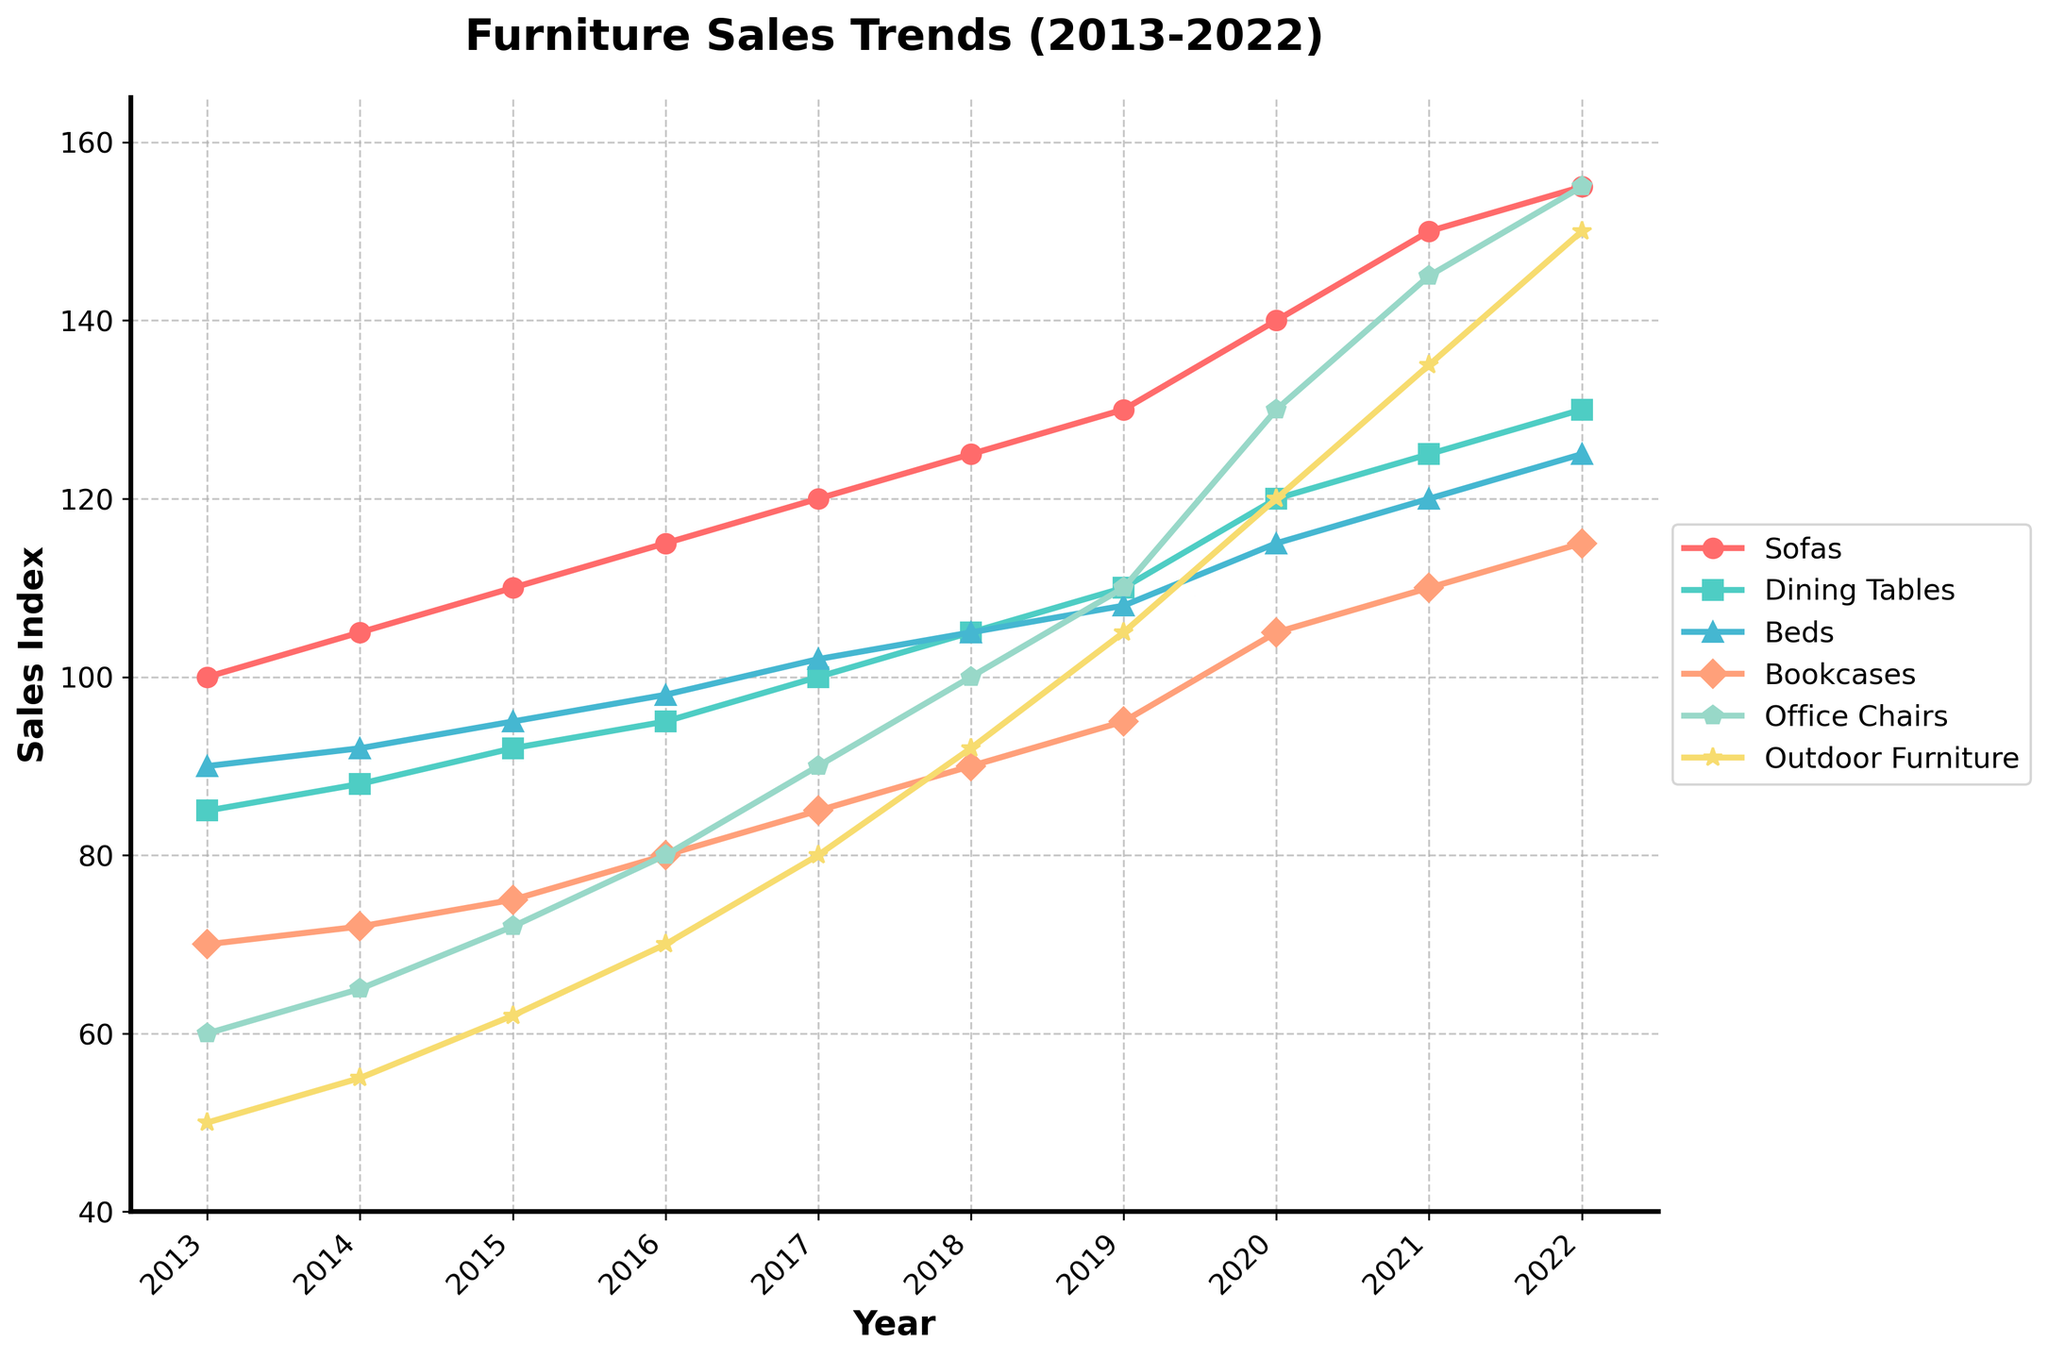What was the sales index of Sofas in 2022? The sales index for Sofas in 2022 is directly read from the figure. Look for the label "Sofas" in the legend, follow the plot line for "Sofas" over to the year 2022, and read the corresponding value on the y-axis.
Answer: 155 Which product category showed the highest increase in sales from 2013 to 2022? To find the highest increase, calculate the difference between the values for 2022 and 2013 for each category. Sofas: 155-100=55, Dining Tables: 130-85=45, Beds: 125-90=35, Bookcases: 115-70=45, Office Chairs: 155-60=95, Outdoor Furniture: 150-50=100. The highest value is for Outdoor Furniture (100).
Answer: Outdoor Furniture How do the trends for Office Chairs and Dining Tables compare from 2013 to 2022? Look at the lines representing "Office Chairs" and "Dining Tables". Identify the starting point (2013) and the ending point (2022) for each line. Office Chairs increased from 60 to 155, and Dining Tables increased from 85 to 130. The increase in Office Chairs is larger than in Dining Tables.
Answer: Office Chairs increased more What is the sum of the sales indexes for Bookcases and Outdoor Furniture in 2016? Find the sales indexes for Bookcases and Outdoor Furniture in 2016 from the figure. Bookcases: 80, Outdoor Furniture: 70. Add these values: 80 + 70 = 150.
Answer: 150 What color represents Dining Tables in the chart? Identify the color of the line and markers for Dining Tables by looking at the legend and finding "Dining Tables". The color associated with Dining Tables in the legend is green.
Answer: green What is the average sales index for Beds over the decade? Find the sales indexes for Beds from 2013 to 2022: 90, 92, 95, 98, 102, 105, 108, 115, 120, and 125. Sum these values: 90+92+95+98+102+105+108+115+120+125=1050. Divide by the number of years (10): 1050/10=105.
Answer: 105 Between which two years did Office Chairs experience the most significant increase in sales? Calculate the yearly differences for Office Chairs: (2014-2013: 65-60=5), (2015-2014: 72-65=7), (2016-2015: 80-72=8), (2017-2016: 90-80=10), (2018-2017: 100-90=10), (2019-2018: 110-100=10), (2020-2019: 130-110=20), (2021-2020: 145-130=15), (2022-2021: 155-145=10). The largest increase is between 2019 and 2020, which is 20.
Answer: 2019 and 2020 What is the median sales index of Sofas over the decade? List the sales indexes for Sofas: 100, 105, 110, 115, 120, 125, 130, 140, 150, 155. Arrange them in ascending order (already sorted) and find the median (middle value). Since there are 10 values, median is the average of the 5th and 6th values: (120+125)/2=122.5.
Answer: 122.5 